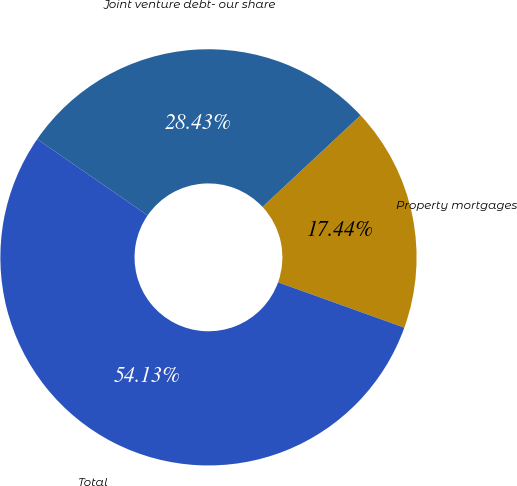Convert chart to OTSL. <chart><loc_0><loc_0><loc_500><loc_500><pie_chart><fcel>Property mortgages<fcel>Joint venture debt- our share<fcel>Total<nl><fcel>17.44%<fcel>28.43%<fcel>54.13%<nl></chart> 